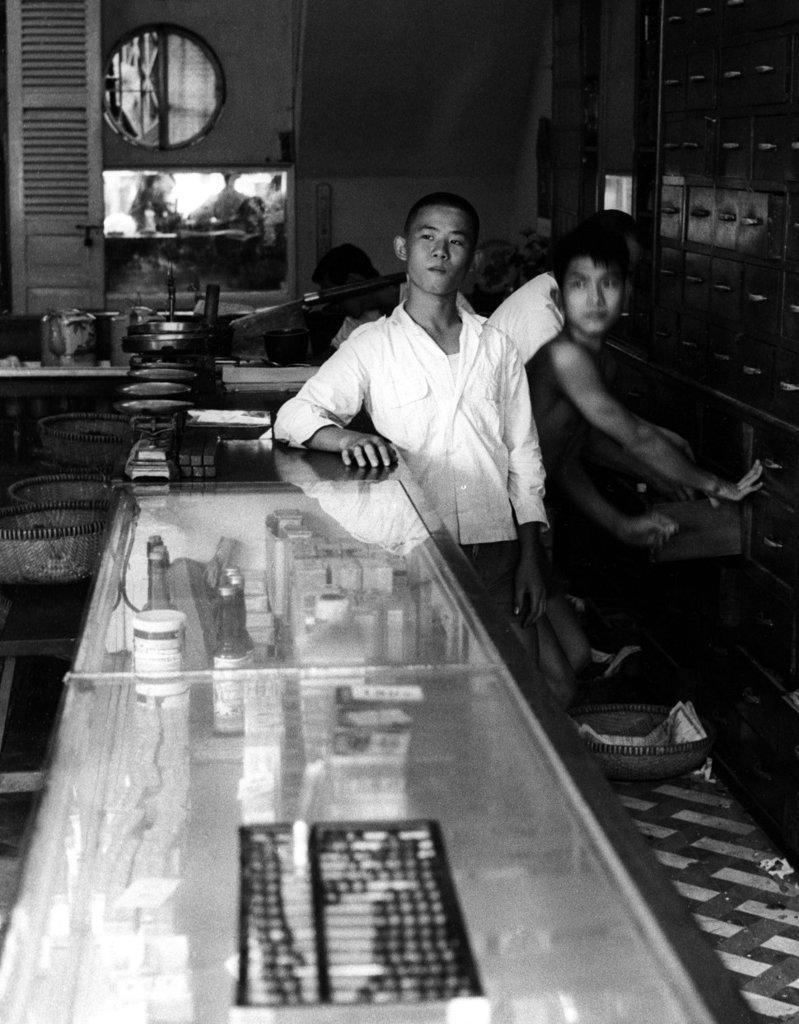Can you describe this image briefly? Here we can see a black and white photograph, in this we can find few people and baskets, on the left side of the image we can find a weighing machine, bottles and other things, on the right side of the image we can see drawers. 